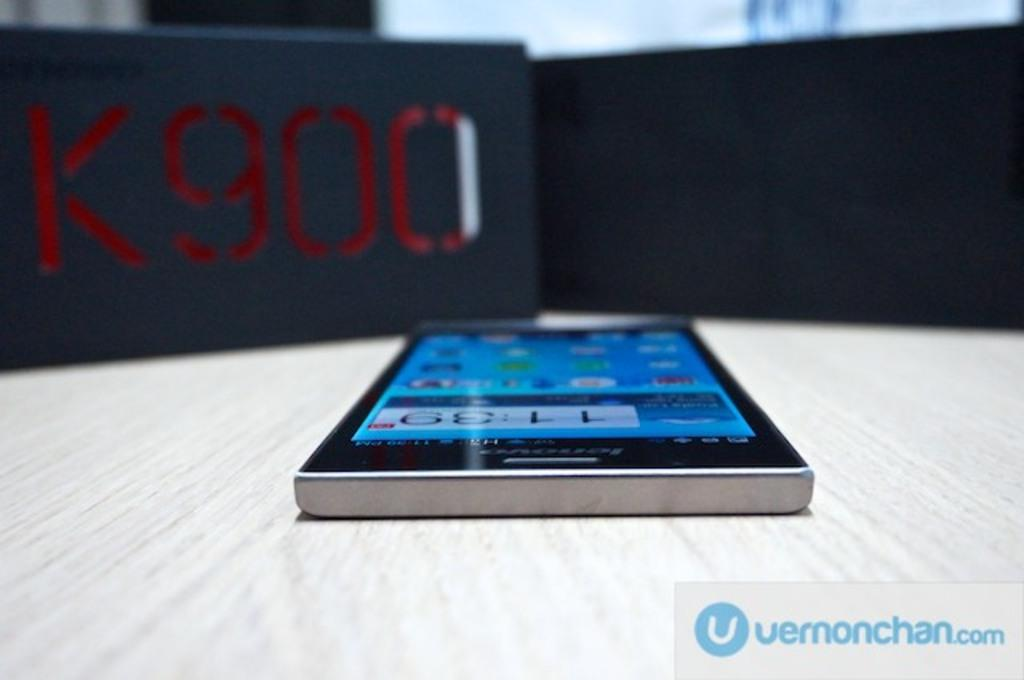<image>
Present a compact description of the photo's key features. A top view of a smartphone in an image provided by vernonchan.com 